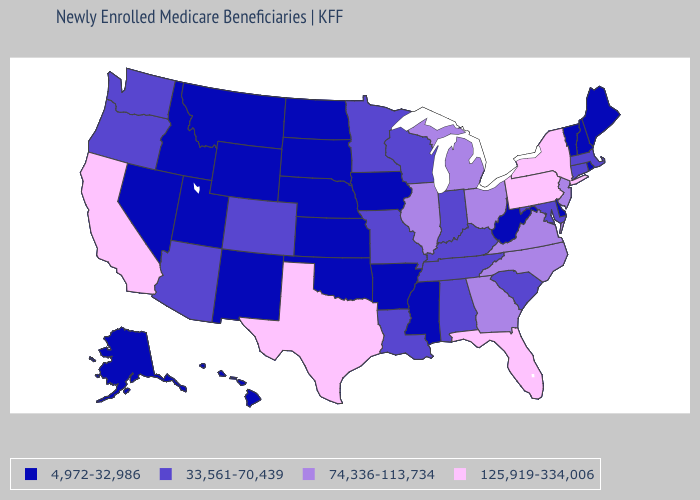What is the value of Georgia?
Concise answer only. 74,336-113,734. Does California have a higher value than New York?
Quick response, please. No. What is the value of Ohio?
Give a very brief answer. 74,336-113,734. What is the lowest value in the West?
Answer briefly. 4,972-32,986. What is the value of Utah?
Write a very short answer. 4,972-32,986. Name the states that have a value in the range 4,972-32,986?
Concise answer only. Alaska, Arkansas, Delaware, Hawaii, Idaho, Iowa, Kansas, Maine, Mississippi, Montana, Nebraska, Nevada, New Hampshire, New Mexico, North Dakota, Oklahoma, Rhode Island, South Dakota, Utah, Vermont, West Virginia, Wyoming. Which states have the highest value in the USA?
Write a very short answer. California, Florida, New York, Pennsylvania, Texas. Does Pennsylvania have the highest value in the USA?
Be succinct. Yes. What is the highest value in the USA?
Write a very short answer. 125,919-334,006. Among the states that border Arizona , does California have the highest value?
Give a very brief answer. Yes. Among the states that border Vermont , does Massachusetts have the lowest value?
Answer briefly. No. What is the value of Oregon?
Give a very brief answer. 33,561-70,439. What is the lowest value in the West?
Keep it brief. 4,972-32,986. What is the value of Oklahoma?
Concise answer only. 4,972-32,986. Among the states that border West Virginia , which have the lowest value?
Keep it brief. Kentucky, Maryland. 